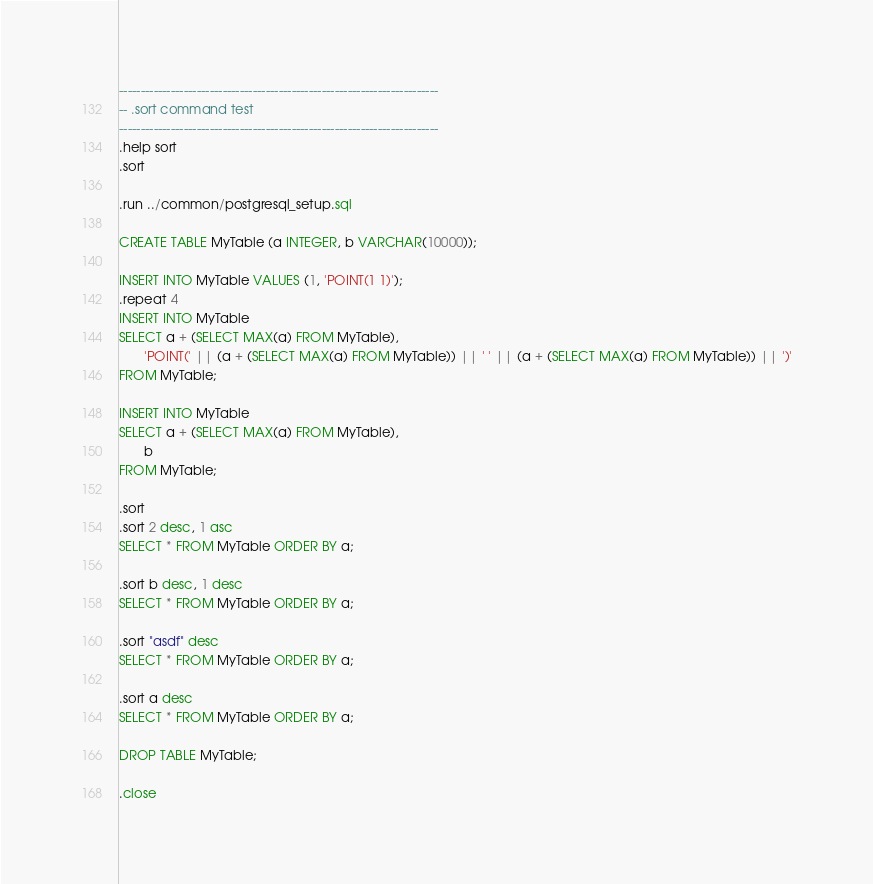<code> <loc_0><loc_0><loc_500><loc_500><_SQL_>--------------------------------------------------------------------------
-- .sort command test
--------------------------------------------------------------------------
.help sort
.sort

.run ../common/postgresql_setup.sql

CREATE TABLE MyTable (a INTEGER, b VARCHAR(10000));

INSERT INTO MyTable VALUES (1, 'POINT(1 1)');
.repeat 4
INSERT INTO MyTable
SELECT a + (SELECT MAX(a) FROM MyTable),
       'POINT(' || (a + (SELECT MAX(a) FROM MyTable)) || ' ' || (a + (SELECT MAX(a) FROM MyTable)) || ')'
FROM MyTable;

INSERT INTO MyTable
SELECT a + (SELECT MAX(a) FROM MyTable),
       b
FROM MyTable;

.sort
.sort 2 desc, 1 asc
SELECT * FROM MyTable ORDER BY a;

.sort b desc, 1 desc
SELECT * FROM MyTable ORDER BY a;

.sort "asdf" desc
SELECT * FROM MyTable ORDER BY a;

.sort a desc
SELECT * FROM MyTable ORDER BY a;

DROP TABLE MyTable;

.close
</code> 